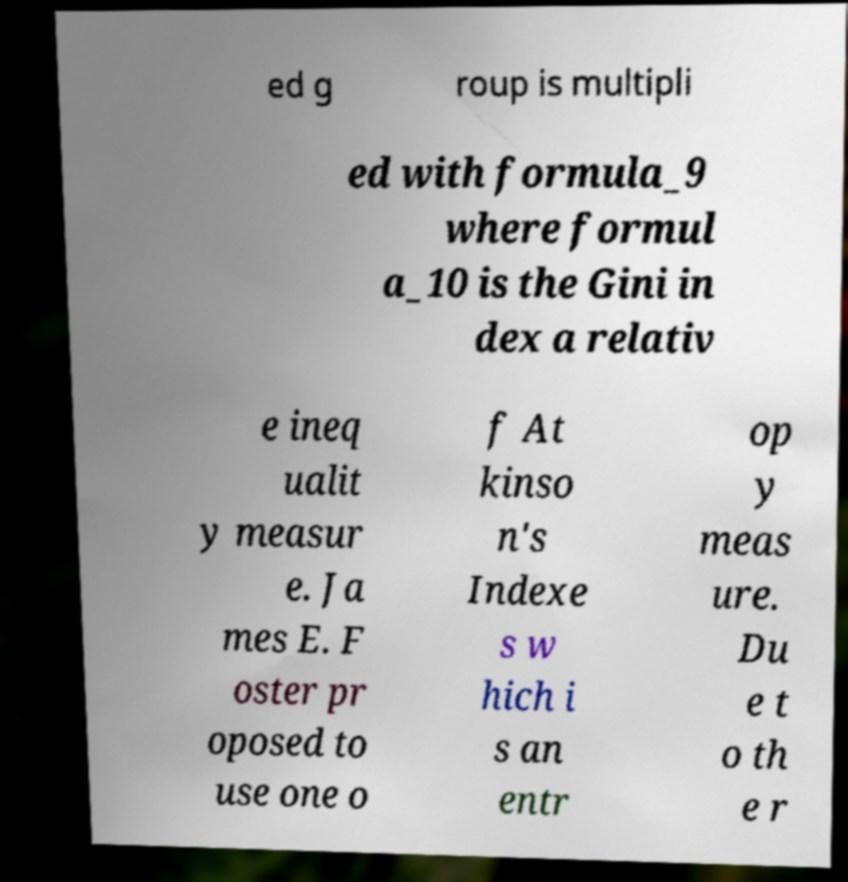Could you assist in decoding the text presented in this image and type it out clearly? ed g roup is multipli ed with formula_9 where formul a_10 is the Gini in dex a relativ e ineq ualit y measur e. Ja mes E. F oster pr oposed to use one o f At kinso n's Indexe s w hich i s an entr op y meas ure. Du e t o th e r 